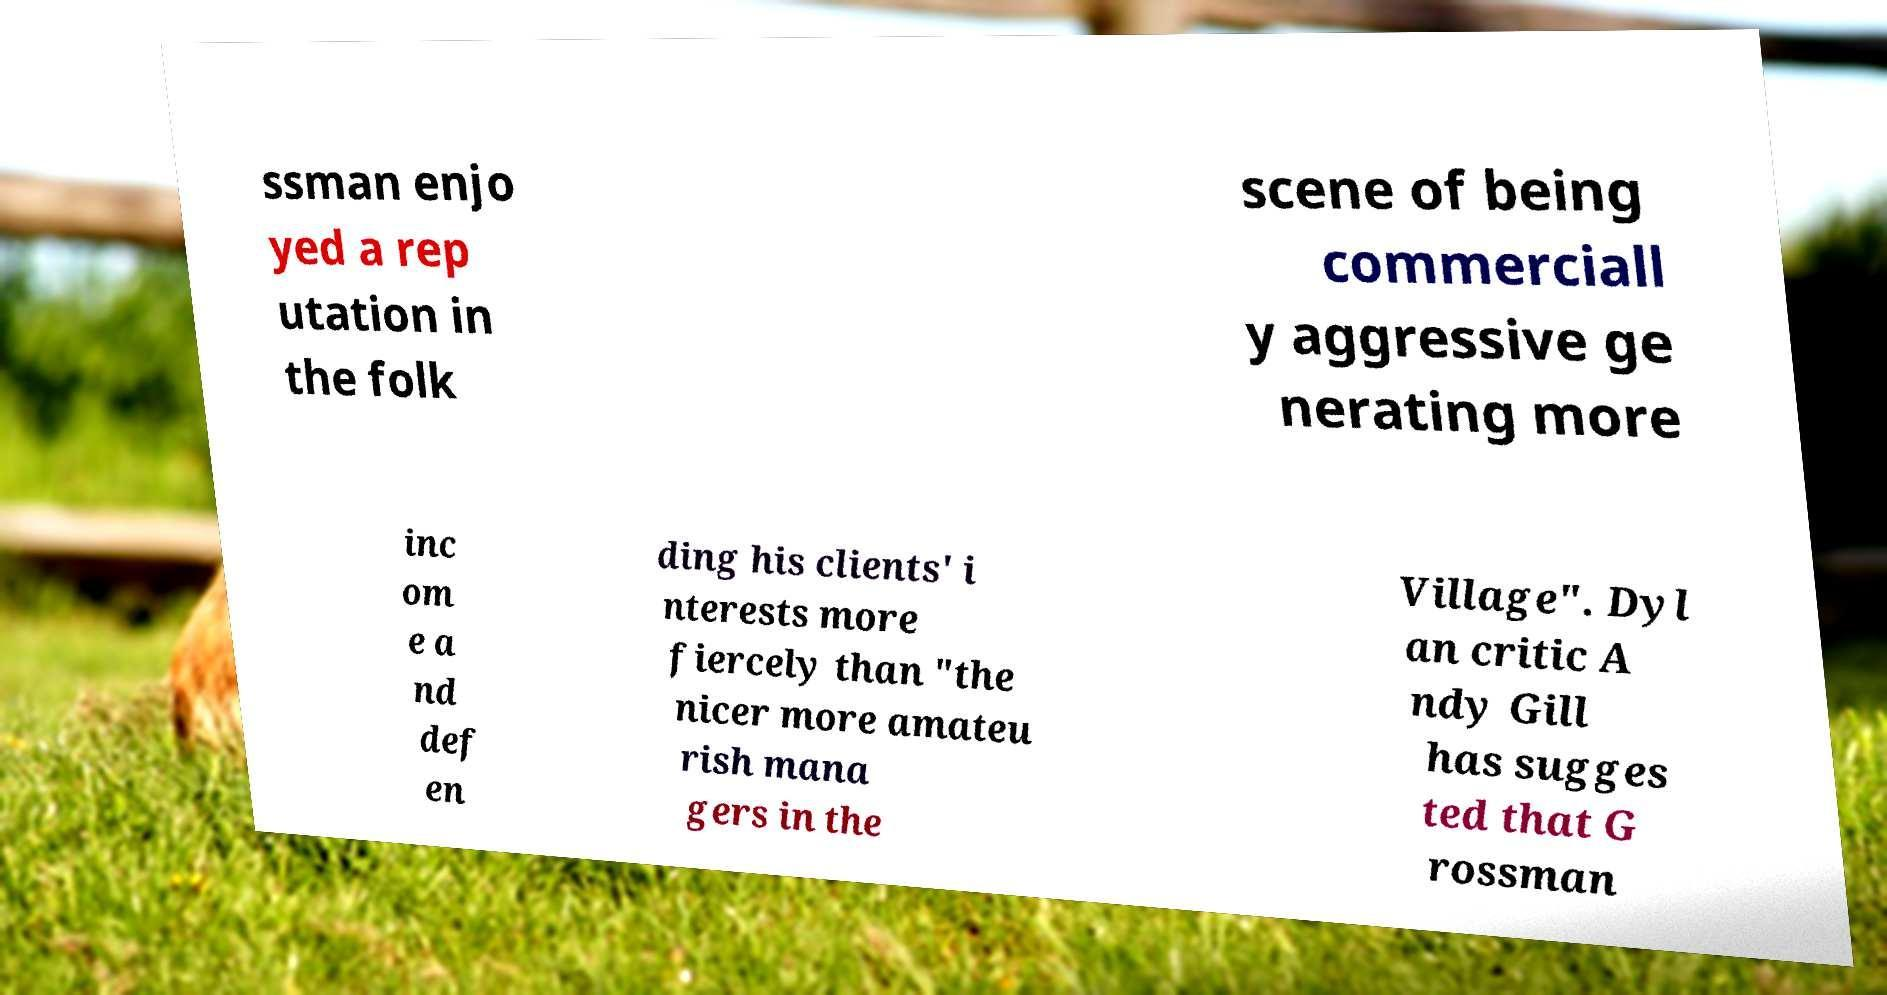Please read and relay the text visible in this image. What does it say? ssman enjo yed a rep utation in the folk scene of being commerciall y aggressive ge nerating more inc om e a nd def en ding his clients' i nterests more fiercely than "the nicer more amateu rish mana gers in the Village". Dyl an critic A ndy Gill has sugges ted that G rossman 